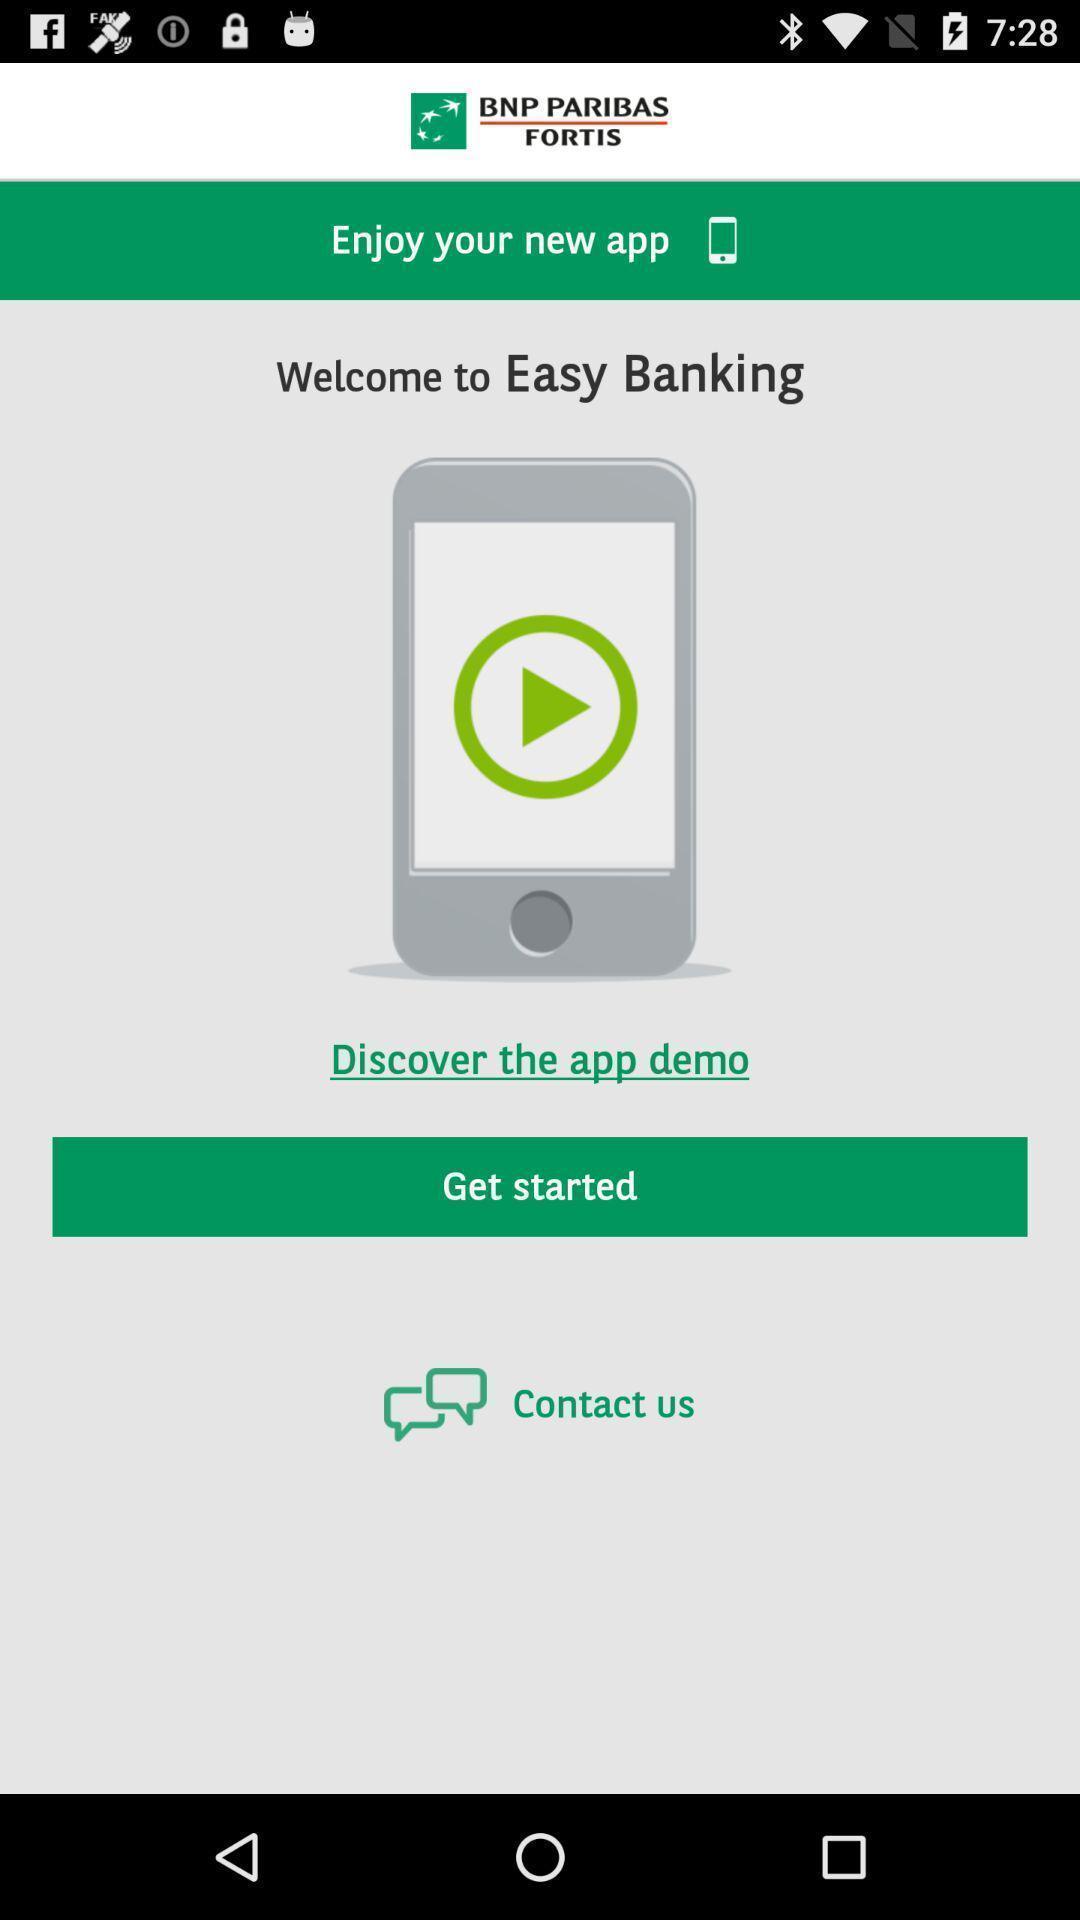Explain what's happening in this screen capture. Welcome page of an banking app. 